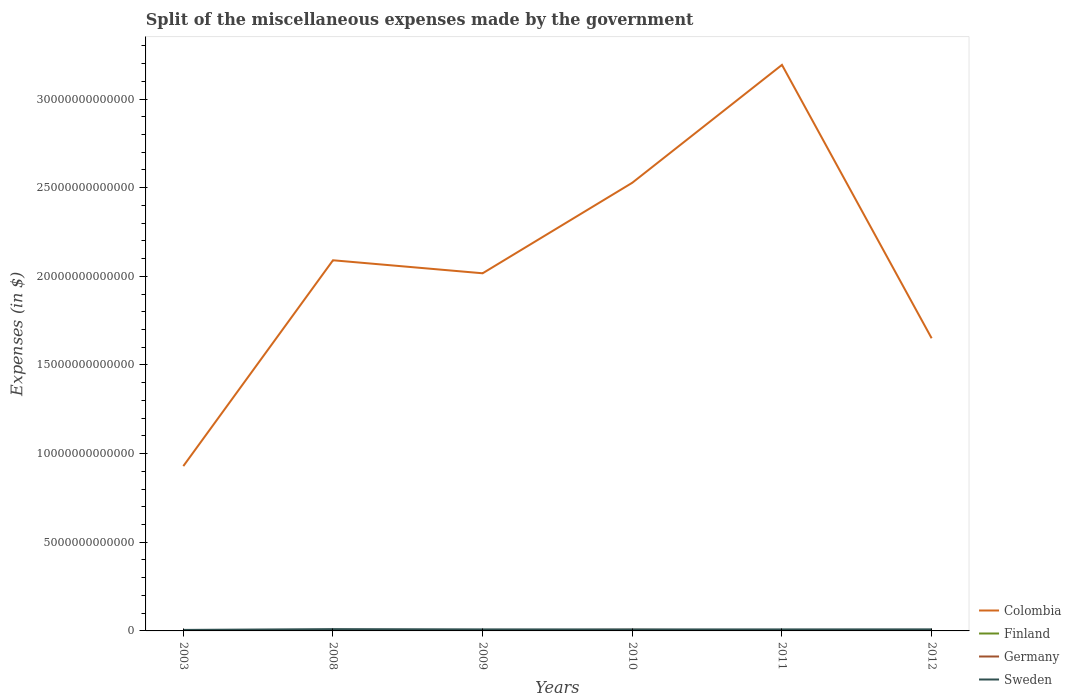How many different coloured lines are there?
Provide a short and direct response. 4. Across all years, what is the maximum miscellaneous expenses made by the government in Germany?
Your answer should be very brief. 2.79e+1. In which year was the miscellaneous expenses made by the government in Colombia maximum?
Your response must be concise. 2003. What is the total miscellaneous expenses made by the government in Colombia in the graph?
Provide a succinct answer. -7.21e+12. What is the difference between the highest and the second highest miscellaneous expenses made by the government in Sweden?
Your answer should be very brief. 4.51e+1. Is the miscellaneous expenses made by the government in Sweden strictly greater than the miscellaneous expenses made by the government in Germany over the years?
Give a very brief answer. No. How many years are there in the graph?
Ensure brevity in your answer.  6. What is the difference between two consecutive major ticks on the Y-axis?
Give a very brief answer. 5.00e+12. Are the values on the major ticks of Y-axis written in scientific E-notation?
Provide a short and direct response. No. Does the graph contain any zero values?
Your answer should be very brief. No. Does the graph contain grids?
Provide a succinct answer. No. Where does the legend appear in the graph?
Provide a succinct answer. Bottom right. How many legend labels are there?
Provide a short and direct response. 4. How are the legend labels stacked?
Keep it short and to the point. Vertical. What is the title of the graph?
Give a very brief answer. Split of the miscellaneous expenses made by the government. What is the label or title of the X-axis?
Offer a terse response. Years. What is the label or title of the Y-axis?
Your response must be concise. Expenses (in $). What is the Expenses (in $) of Colombia in 2003?
Give a very brief answer. 9.30e+12. What is the Expenses (in $) in Finland in 2003?
Your answer should be compact. 3.70e+09. What is the Expenses (in $) of Germany in 2003?
Offer a very short reply. 2.79e+1. What is the Expenses (in $) of Sweden in 2003?
Give a very brief answer. 5.66e+1. What is the Expenses (in $) in Colombia in 2008?
Offer a terse response. 2.09e+13. What is the Expenses (in $) in Finland in 2008?
Ensure brevity in your answer.  4.78e+09. What is the Expenses (in $) of Germany in 2008?
Provide a short and direct response. 3.09e+1. What is the Expenses (in $) of Sweden in 2008?
Provide a succinct answer. 1.02e+11. What is the Expenses (in $) in Colombia in 2009?
Ensure brevity in your answer.  2.02e+13. What is the Expenses (in $) in Finland in 2009?
Provide a short and direct response. 5.07e+09. What is the Expenses (in $) of Germany in 2009?
Offer a very short reply. 3.68e+1. What is the Expenses (in $) in Sweden in 2009?
Provide a succinct answer. 8.61e+1. What is the Expenses (in $) of Colombia in 2010?
Your answer should be very brief. 2.53e+13. What is the Expenses (in $) in Finland in 2010?
Provide a short and direct response. 5.12e+09. What is the Expenses (in $) in Germany in 2010?
Provide a succinct answer. 6.21e+1. What is the Expenses (in $) in Sweden in 2010?
Give a very brief answer. 8.43e+1. What is the Expenses (in $) in Colombia in 2011?
Provide a succinct answer. 3.19e+13. What is the Expenses (in $) of Finland in 2011?
Make the answer very short. 5.28e+09. What is the Expenses (in $) in Germany in 2011?
Keep it short and to the point. 2.88e+1. What is the Expenses (in $) in Sweden in 2011?
Provide a succinct answer. 8.53e+1. What is the Expenses (in $) of Colombia in 2012?
Your response must be concise. 1.65e+13. What is the Expenses (in $) in Finland in 2012?
Ensure brevity in your answer.  5.35e+09. What is the Expenses (in $) of Germany in 2012?
Make the answer very short. 2.88e+1. What is the Expenses (in $) of Sweden in 2012?
Offer a terse response. 8.78e+1. Across all years, what is the maximum Expenses (in $) in Colombia?
Keep it short and to the point. 3.19e+13. Across all years, what is the maximum Expenses (in $) in Finland?
Your answer should be compact. 5.35e+09. Across all years, what is the maximum Expenses (in $) in Germany?
Make the answer very short. 6.21e+1. Across all years, what is the maximum Expenses (in $) of Sweden?
Provide a short and direct response. 1.02e+11. Across all years, what is the minimum Expenses (in $) in Colombia?
Keep it short and to the point. 9.30e+12. Across all years, what is the minimum Expenses (in $) of Finland?
Keep it short and to the point. 3.70e+09. Across all years, what is the minimum Expenses (in $) in Germany?
Make the answer very short. 2.79e+1. Across all years, what is the minimum Expenses (in $) in Sweden?
Offer a very short reply. 5.66e+1. What is the total Expenses (in $) of Colombia in the graph?
Offer a very short reply. 1.24e+14. What is the total Expenses (in $) of Finland in the graph?
Give a very brief answer. 2.93e+1. What is the total Expenses (in $) of Germany in the graph?
Offer a terse response. 2.15e+11. What is the total Expenses (in $) of Sweden in the graph?
Offer a very short reply. 5.02e+11. What is the difference between the Expenses (in $) in Colombia in 2003 and that in 2008?
Offer a very short reply. -1.16e+13. What is the difference between the Expenses (in $) in Finland in 2003 and that in 2008?
Offer a very short reply. -1.08e+09. What is the difference between the Expenses (in $) in Germany in 2003 and that in 2008?
Make the answer very short. -2.96e+09. What is the difference between the Expenses (in $) in Sweden in 2003 and that in 2008?
Ensure brevity in your answer.  -4.51e+1. What is the difference between the Expenses (in $) of Colombia in 2003 and that in 2009?
Ensure brevity in your answer.  -1.09e+13. What is the difference between the Expenses (in $) of Finland in 2003 and that in 2009?
Keep it short and to the point. -1.37e+09. What is the difference between the Expenses (in $) of Germany in 2003 and that in 2009?
Your answer should be compact. -8.92e+09. What is the difference between the Expenses (in $) in Sweden in 2003 and that in 2009?
Your answer should be compact. -2.95e+1. What is the difference between the Expenses (in $) in Colombia in 2003 and that in 2010?
Ensure brevity in your answer.  -1.60e+13. What is the difference between the Expenses (in $) in Finland in 2003 and that in 2010?
Make the answer very short. -1.42e+09. What is the difference between the Expenses (in $) of Germany in 2003 and that in 2010?
Your answer should be compact. -3.42e+1. What is the difference between the Expenses (in $) of Sweden in 2003 and that in 2010?
Make the answer very short. -2.77e+1. What is the difference between the Expenses (in $) in Colombia in 2003 and that in 2011?
Provide a succinct answer. -2.26e+13. What is the difference between the Expenses (in $) in Finland in 2003 and that in 2011?
Your answer should be compact. -1.58e+09. What is the difference between the Expenses (in $) of Germany in 2003 and that in 2011?
Provide a short and direct response. -8.70e+08. What is the difference between the Expenses (in $) of Sweden in 2003 and that in 2011?
Ensure brevity in your answer.  -2.87e+1. What is the difference between the Expenses (in $) of Colombia in 2003 and that in 2012?
Give a very brief answer. -7.21e+12. What is the difference between the Expenses (in $) of Finland in 2003 and that in 2012?
Your answer should be very brief. -1.66e+09. What is the difference between the Expenses (in $) in Germany in 2003 and that in 2012?
Offer a very short reply. -8.30e+08. What is the difference between the Expenses (in $) in Sweden in 2003 and that in 2012?
Offer a terse response. -3.12e+1. What is the difference between the Expenses (in $) in Colombia in 2008 and that in 2009?
Keep it short and to the point. 7.33e+11. What is the difference between the Expenses (in $) of Finland in 2008 and that in 2009?
Offer a very short reply. -2.94e+08. What is the difference between the Expenses (in $) in Germany in 2008 and that in 2009?
Your response must be concise. -5.96e+09. What is the difference between the Expenses (in $) of Sweden in 2008 and that in 2009?
Provide a succinct answer. 1.56e+1. What is the difference between the Expenses (in $) in Colombia in 2008 and that in 2010?
Offer a terse response. -4.37e+12. What is the difference between the Expenses (in $) of Finland in 2008 and that in 2010?
Ensure brevity in your answer.  -3.39e+08. What is the difference between the Expenses (in $) in Germany in 2008 and that in 2010?
Your answer should be compact. -3.12e+1. What is the difference between the Expenses (in $) in Sweden in 2008 and that in 2010?
Make the answer very short. 1.74e+1. What is the difference between the Expenses (in $) in Colombia in 2008 and that in 2011?
Provide a short and direct response. -1.10e+13. What is the difference between the Expenses (in $) in Finland in 2008 and that in 2011?
Make the answer very short. -4.97e+08. What is the difference between the Expenses (in $) of Germany in 2008 and that in 2011?
Your answer should be compact. 2.09e+09. What is the difference between the Expenses (in $) of Sweden in 2008 and that in 2011?
Provide a short and direct response. 1.63e+1. What is the difference between the Expenses (in $) in Colombia in 2008 and that in 2012?
Give a very brief answer. 4.40e+12. What is the difference between the Expenses (in $) in Finland in 2008 and that in 2012?
Provide a succinct answer. -5.75e+08. What is the difference between the Expenses (in $) in Germany in 2008 and that in 2012?
Provide a short and direct response. 2.13e+09. What is the difference between the Expenses (in $) of Sweden in 2008 and that in 2012?
Your answer should be compact. 1.38e+1. What is the difference between the Expenses (in $) of Colombia in 2009 and that in 2010?
Offer a terse response. -5.11e+12. What is the difference between the Expenses (in $) in Finland in 2009 and that in 2010?
Make the answer very short. -4.50e+07. What is the difference between the Expenses (in $) in Germany in 2009 and that in 2010?
Provide a succinct answer. -2.52e+1. What is the difference between the Expenses (in $) of Sweden in 2009 and that in 2010?
Offer a very short reply. 1.77e+09. What is the difference between the Expenses (in $) of Colombia in 2009 and that in 2011?
Provide a succinct answer. -1.18e+13. What is the difference between the Expenses (in $) in Finland in 2009 and that in 2011?
Your response must be concise. -2.03e+08. What is the difference between the Expenses (in $) in Germany in 2009 and that in 2011?
Keep it short and to the point. 8.05e+09. What is the difference between the Expenses (in $) in Sweden in 2009 and that in 2011?
Provide a short and direct response. 7.40e+08. What is the difference between the Expenses (in $) in Colombia in 2009 and that in 2012?
Give a very brief answer. 3.66e+12. What is the difference between the Expenses (in $) of Finland in 2009 and that in 2012?
Provide a short and direct response. -2.81e+08. What is the difference between the Expenses (in $) in Germany in 2009 and that in 2012?
Ensure brevity in your answer.  8.09e+09. What is the difference between the Expenses (in $) in Sweden in 2009 and that in 2012?
Offer a very short reply. -1.77e+09. What is the difference between the Expenses (in $) of Colombia in 2010 and that in 2011?
Provide a succinct answer. -6.65e+12. What is the difference between the Expenses (in $) in Finland in 2010 and that in 2011?
Offer a very short reply. -1.58e+08. What is the difference between the Expenses (in $) in Germany in 2010 and that in 2011?
Make the answer very short. 3.33e+1. What is the difference between the Expenses (in $) in Sweden in 2010 and that in 2011?
Give a very brief answer. -1.03e+09. What is the difference between the Expenses (in $) of Colombia in 2010 and that in 2012?
Offer a terse response. 8.77e+12. What is the difference between the Expenses (in $) of Finland in 2010 and that in 2012?
Give a very brief answer. -2.36e+08. What is the difference between the Expenses (in $) in Germany in 2010 and that in 2012?
Offer a very short reply. 3.33e+1. What is the difference between the Expenses (in $) in Sweden in 2010 and that in 2012?
Ensure brevity in your answer.  -3.54e+09. What is the difference between the Expenses (in $) in Colombia in 2011 and that in 2012?
Offer a terse response. 1.54e+13. What is the difference between the Expenses (in $) of Finland in 2011 and that in 2012?
Your response must be concise. -7.80e+07. What is the difference between the Expenses (in $) in Germany in 2011 and that in 2012?
Ensure brevity in your answer.  4.00e+07. What is the difference between the Expenses (in $) in Sweden in 2011 and that in 2012?
Offer a very short reply. -2.51e+09. What is the difference between the Expenses (in $) in Colombia in 2003 and the Expenses (in $) in Finland in 2008?
Ensure brevity in your answer.  9.29e+12. What is the difference between the Expenses (in $) of Colombia in 2003 and the Expenses (in $) of Germany in 2008?
Offer a very short reply. 9.26e+12. What is the difference between the Expenses (in $) in Colombia in 2003 and the Expenses (in $) in Sweden in 2008?
Offer a very short reply. 9.19e+12. What is the difference between the Expenses (in $) of Finland in 2003 and the Expenses (in $) of Germany in 2008?
Your answer should be very brief. -2.72e+1. What is the difference between the Expenses (in $) in Finland in 2003 and the Expenses (in $) in Sweden in 2008?
Keep it short and to the point. -9.80e+1. What is the difference between the Expenses (in $) of Germany in 2003 and the Expenses (in $) of Sweden in 2008?
Your response must be concise. -7.38e+1. What is the difference between the Expenses (in $) of Colombia in 2003 and the Expenses (in $) of Finland in 2009?
Provide a short and direct response. 9.29e+12. What is the difference between the Expenses (in $) in Colombia in 2003 and the Expenses (in $) in Germany in 2009?
Ensure brevity in your answer.  9.26e+12. What is the difference between the Expenses (in $) of Colombia in 2003 and the Expenses (in $) of Sweden in 2009?
Offer a terse response. 9.21e+12. What is the difference between the Expenses (in $) of Finland in 2003 and the Expenses (in $) of Germany in 2009?
Your answer should be compact. -3.31e+1. What is the difference between the Expenses (in $) of Finland in 2003 and the Expenses (in $) of Sweden in 2009?
Your answer should be very brief. -8.24e+1. What is the difference between the Expenses (in $) of Germany in 2003 and the Expenses (in $) of Sweden in 2009?
Provide a succinct answer. -5.81e+1. What is the difference between the Expenses (in $) of Colombia in 2003 and the Expenses (in $) of Finland in 2010?
Keep it short and to the point. 9.29e+12. What is the difference between the Expenses (in $) of Colombia in 2003 and the Expenses (in $) of Germany in 2010?
Give a very brief answer. 9.23e+12. What is the difference between the Expenses (in $) in Colombia in 2003 and the Expenses (in $) in Sweden in 2010?
Offer a terse response. 9.21e+12. What is the difference between the Expenses (in $) in Finland in 2003 and the Expenses (in $) in Germany in 2010?
Your answer should be very brief. -5.84e+1. What is the difference between the Expenses (in $) of Finland in 2003 and the Expenses (in $) of Sweden in 2010?
Offer a very short reply. -8.06e+1. What is the difference between the Expenses (in $) in Germany in 2003 and the Expenses (in $) in Sweden in 2010?
Make the answer very short. -5.64e+1. What is the difference between the Expenses (in $) of Colombia in 2003 and the Expenses (in $) of Finland in 2011?
Keep it short and to the point. 9.29e+12. What is the difference between the Expenses (in $) of Colombia in 2003 and the Expenses (in $) of Germany in 2011?
Ensure brevity in your answer.  9.27e+12. What is the difference between the Expenses (in $) of Colombia in 2003 and the Expenses (in $) of Sweden in 2011?
Give a very brief answer. 9.21e+12. What is the difference between the Expenses (in $) of Finland in 2003 and the Expenses (in $) of Germany in 2011?
Give a very brief answer. -2.51e+1. What is the difference between the Expenses (in $) in Finland in 2003 and the Expenses (in $) in Sweden in 2011?
Your answer should be very brief. -8.16e+1. What is the difference between the Expenses (in $) of Germany in 2003 and the Expenses (in $) of Sweden in 2011?
Provide a short and direct response. -5.74e+1. What is the difference between the Expenses (in $) of Colombia in 2003 and the Expenses (in $) of Finland in 2012?
Provide a succinct answer. 9.29e+12. What is the difference between the Expenses (in $) in Colombia in 2003 and the Expenses (in $) in Germany in 2012?
Provide a short and direct response. 9.27e+12. What is the difference between the Expenses (in $) in Colombia in 2003 and the Expenses (in $) in Sweden in 2012?
Offer a terse response. 9.21e+12. What is the difference between the Expenses (in $) in Finland in 2003 and the Expenses (in $) in Germany in 2012?
Your response must be concise. -2.51e+1. What is the difference between the Expenses (in $) of Finland in 2003 and the Expenses (in $) of Sweden in 2012?
Keep it short and to the point. -8.41e+1. What is the difference between the Expenses (in $) of Germany in 2003 and the Expenses (in $) of Sweden in 2012?
Your response must be concise. -5.99e+1. What is the difference between the Expenses (in $) of Colombia in 2008 and the Expenses (in $) of Finland in 2009?
Keep it short and to the point. 2.09e+13. What is the difference between the Expenses (in $) of Colombia in 2008 and the Expenses (in $) of Germany in 2009?
Provide a short and direct response. 2.09e+13. What is the difference between the Expenses (in $) of Colombia in 2008 and the Expenses (in $) of Sweden in 2009?
Give a very brief answer. 2.08e+13. What is the difference between the Expenses (in $) of Finland in 2008 and the Expenses (in $) of Germany in 2009?
Your response must be concise. -3.21e+1. What is the difference between the Expenses (in $) in Finland in 2008 and the Expenses (in $) in Sweden in 2009?
Provide a short and direct response. -8.13e+1. What is the difference between the Expenses (in $) in Germany in 2008 and the Expenses (in $) in Sweden in 2009?
Your answer should be compact. -5.52e+1. What is the difference between the Expenses (in $) of Colombia in 2008 and the Expenses (in $) of Finland in 2010?
Keep it short and to the point. 2.09e+13. What is the difference between the Expenses (in $) of Colombia in 2008 and the Expenses (in $) of Germany in 2010?
Offer a terse response. 2.08e+13. What is the difference between the Expenses (in $) in Colombia in 2008 and the Expenses (in $) in Sweden in 2010?
Keep it short and to the point. 2.08e+13. What is the difference between the Expenses (in $) of Finland in 2008 and the Expenses (in $) of Germany in 2010?
Provide a short and direct response. -5.73e+1. What is the difference between the Expenses (in $) of Finland in 2008 and the Expenses (in $) of Sweden in 2010?
Keep it short and to the point. -7.95e+1. What is the difference between the Expenses (in $) in Germany in 2008 and the Expenses (in $) in Sweden in 2010?
Provide a succinct answer. -5.34e+1. What is the difference between the Expenses (in $) in Colombia in 2008 and the Expenses (in $) in Finland in 2011?
Keep it short and to the point. 2.09e+13. What is the difference between the Expenses (in $) of Colombia in 2008 and the Expenses (in $) of Germany in 2011?
Make the answer very short. 2.09e+13. What is the difference between the Expenses (in $) in Colombia in 2008 and the Expenses (in $) in Sweden in 2011?
Your response must be concise. 2.08e+13. What is the difference between the Expenses (in $) of Finland in 2008 and the Expenses (in $) of Germany in 2011?
Offer a very short reply. -2.40e+1. What is the difference between the Expenses (in $) in Finland in 2008 and the Expenses (in $) in Sweden in 2011?
Provide a short and direct response. -8.05e+1. What is the difference between the Expenses (in $) in Germany in 2008 and the Expenses (in $) in Sweden in 2011?
Your answer should be very brief. -5.44e+1. What is the difference between the Expenses (in $) in Colombia in 2008 and the Expenses (in $) in Finland in 2012?
Provide a succinct answer. 2.09e+13. What is the difference between the Expenses (in $) in Colombia in 2008 and the Expenses (in $) in Germany in 2012?
Provide a short and direct response. 2.09e+13. What is the difference between the Expenses (in $) of Colombia in 2008 and the Expenses (in $) of Sweden in 2012?
Give a very brief answer. 2.08e+13. What is the difference between the Expenses (in $) of Finland in 2008 and the Expenses (in $) of Germany in 2012?
Offer a terse response. -2.40e+1. What is the difference between the Expenses (in $) in Finland in 2008 and the Expenses (in $) in Sweden in 2012?
Ensure brevity in your answer.  -8.31e+1. What is the difference between the Expenses (in $) in Germany in 2008 and the Expenses (in $) in Sweden in 2012?
Keep it short and to the point. -5.70e+1. What is the difference between the Expenses (in $) in Colombia in 2009 and the Expenses (in $) in Finland in 2010?
Your answer should be compact. 2.02e+13. What is the difference between the Expenses (in $) in Colombia in 2009 and the Expenses (in $) in Germany in 2010?
Your answer should be compact. 2.01e+13. What is the difference between the Expenses (in $) in Colombia in 2009 and the Expenses (in $) in Sweden in 2010?
Provide a succinct answer. 2.01e+13. What is the difference between the Expenses (in $) of Finland in 2009 and the Expenses (in $) of Germany in 2010?
Offer a very short reply. -5.70e+1. What is the difference between the Expenses (in $) of Finland in 2009 and the Expenses (in $) of Sweden in 2010?
Ensure brevity in your answer.  -7.92e+1. What is the difference between the Expenses (in $) of Germany in 2009 and the Expenses (in $) of Sweden in 2010?
Provide a short and direct response. -4.74e+1. What is the difference between the Expenses (in $) of Colombia in 2009 and the Expenses (in $) of Finland in 2011?
Provide a short and direct response. 2.02e+13. What is the difference between the Expenses (in $) of Colombia in 2009 and the Expenses (in $) of Germany in 2011?
Keep it short and to the point. 2.01e+13. What is the difference between the Expenses (in $) of Colombia in 2009 and the Expenses (in $) of Sweden in 2011?
Keep it short and to the point. 2.01e+13. What is the difference between the Expenses (in $) in Finland in 2009 and the Expenses (in $) in Germany in 2011?
Provide a short and direct response. -2.37e+1. What is the difference between the Expenses (in $) of Finland in 2009 and the Expenses (in $) of Sweden in 2011?
Offer a very short reply. -8.03e+1. What is the difference between the Expenses (in $) of Germany in 2009 and the Expenses (in $) of Sweden in 2011?
Provide a short and direct response. -4.85e+1. What is the difference between the Expenses (in $) in Colombia in 2009 and the Expenses (in $) in Finland in 2012?
Give a very brief answer. 2.02e+13. What is the difference between the Expenses (in $) of Colombia in 2009 and the Expenses (in $) of Germany in 2012?
Offer a very short reply. 2.01e+13. What is the difference between the Expenses (in $) in Colombia in 2009 and the Expenses (in $) in Sweden in 2012?
Ensure brevity in your answer.  2.01e+13. What is the difference between the Expenses (in $) of Finland in 2009 and the Expenses (in $) of Germany in 2012?
Offer a terse response. -2.37e+1. What is the difference between the Expenses (in $) of Finland in 2009 and the Expenses (in $) of Sweden in 2012?
Offer a very short reply. -8.28e+1. What is the difference between the Expenses (in $) of Germany in 2009 and the Expenses (in $) of Sweden in 2012?
Offer a terse response. -5.10e+1. What is the difference between the Expenses (in $) in Colombia in 2010 and the Expenses (in $) in Finland in 2011?
Keep it short and to the point. 2.53e+13. What is the difference between the Expenses (in $) of Colombia in 2010 and the Expenses (in $) of Germany in 2011?
Provide a succinct answer. 2.52e+13. What is the difference between the Expenses (in $) of Colombia in 2010 and the Expenses (in $) of Sweden in 2011?
Offer a very short reply. 2.52e+13. What is the difference between the Expenses (in $) of Finland in 2010 and the Expenses (in $) of Germany in 2011?
Your answer should be very brief. -2.37e+1. What is the difference between the Expenses (in $) in Finland in 2010 and the Expenses (in $) in Sweden in 2011?
Give a very brief answer. -8.02e+1. What is the difference between the Expenses (in $) in Germany in 2010 and the Expenses (in $) in Sweden in 2011?
Give a very brief answer. -2.32e+1. What is the difference between the Expenses (in $) of Colombia in 2010 and the Expenses (in $) of Finland in 2012?
Give a very brief answer. 2.53e+13. What is the difference between the Expenses (in $) of Colombia in 2010 and the Expenses (in $) of Germany in 2012?
Give a very brief answer. 2.52e+13. What is the difference between the Expenses (in $) of Colombia in 2010 and the Expenses (in $) of Sweden in 2012?
Provide a short and direct response. 2.52e+13. What is the difference between the Expenses (in $) of Finland in 2010 and the Expenses (in $) of Germany in 2012?
Your response must be concise. -2.36e+1. What is the difference between the Expenses (in $) of Finland in 2010 and the Expenses (in $) of Sweden in 2012?
Ensure brevity in your answer.  -8.27e+1. What is the difference between the Expenses (in $) in Germany in 2010 and the Expenses (in $) in Sweden in 2012?
Make the answer very short. -2.58e+1. What is the difference between the Expenses (in $) in Colombia in 2011 and the Expenses (in $) in Finland in 2012?
Your answer should be very brief. 3.19e+13. What is the difference between the Expenses (in $) of Colombia in 2011 and the Expenses (in $) of Germany in 2012?
Offer a very short reply. 3.19e+13. What is the difference between the Expenses (in $) of Colombia in 2011 and the Expenses (in $) of Sweden in 2012?
Provide a short and direct response. 3.18e+13. What is the difference between the Expenses (in $) of Finland in 2011 and the Expenses (in $) of Germany in 2012?
Your answer should be very brief. -2.35e+1. What is the difference between the Expenses (in $) in Finland in 2011 and the Expenses (in $) in Sweden in 2012?
Give a very brief answer. -8.26e+1. What is the difference between the Expenses (in $) in Germany in 2011 and the Expenses (in $) in Sweden in 2012?
Offer a very short reply. -5.90e+1. What is the average Expenses (in $) of Colombia per year?
Keep it short and to the point. 2.07e+13. What is the average Expenses (in $) in Finland per year?
Your response must be concise. 4.88e+09. What is the average Expenses (in $) of Germany per year?
Provide a succinct answer. 3.59e+1. What is the average Expenses (in $) in Sweden per year?
Keep it short and to the point. 8.36e+1. In the year 2003, what is the difference between the Expenses (in $) in Colombia and Expenses (in $) in Finland?
Make the answer very short. 9.29e+12. In the year 2003, what is the difference between the Expenses (in $) of Colombia and Expenses (in $) of Germany?
Give a very brief answer. 9.27e+12. In the year 2003, what is the difference between the Expenses (in $) of Colombia and Expenses (in $) of Sweden?
Offer a very short reply. 9.24e+12. In the year 2003, what is the difference between the Expenses (in $) of Finland and Expenses (in $) of Germany?
Ensure brevity in your answer.  -2.42e+1. In the year 2003, what is the difference between the Expenses (in $) in Finland and Expenses (in $) in Sweden?
Offer a terse response. -5.29e+1. In the year 2003, what is the difference between the Expenses (in $) in Germany and Expenses (in $) in Sweden?
Your answer should be compact. -2.87e+1. In the year 2008, what is the difference between the Expenses (in $) of Colombia and Expenses (in $) of Finland?
Provide a short and direct response. 2.09e+13. In the year 2008, what is the difference between the Expenses (in $) in Colombia and Expenses (in $) in Germany?
Offer a terse response. 2.09e+13. In the year 2008, what is the difference between the Expenses (in $) of Colombia and Expenses (in $) of Sweden?
Give a very brief answer. 2.08e+13. In the year 2008, what is the difference between the Expenses (in $) in Finland and Expenses (in $) in Germany?
Provide a short and direct response. -2.61e+1. In the year 2008, what is the difference between the Expenses (in $) in Finland and Expenses (in $) in Sweden?
Give a very brief answer. -9.69e+1. In the year 2008, what is the difference between the Expenses (in $) in Germany and Expenses (in $) in Sweden?
Give a very brief answer. -7.08e+1. In the year 2009, what is the difference between the Expenses (in $) in Colombia and Expenses (in $) in Finland?
Provide a succinct answer. 2.02e+13. In the year 2009, what is the difference between the Expenses (in $) of Colombia and Expenses (in $) of Germany?
Your answer should be very brief. 2.01e+13. In the year 2009, what is the difference between the Expenses (in $) of Colombia and Expenses (in $) of Sweden?
Provide a succinct answer. 2.01e+13. In the year 2009, what is the difference between the Expenses (in $) in Finland and Expenses (in $) in Germany?
Ensure brevity in your answer.  -3.18e+1. In the year 2009, what is the difference between the Expenses (in $) in Finland and Expenses (in $) in Sweden?
Your answer should be very brief. -8.10e+1. In the year 2009, what is the difference between the Expenses (in $) of Germany and Expenses (in $) of Sweden?
Your answer should be very brief. -4.92e+1. In the year 2010, what is the difference between the Expenses (in $) of Colombia and Expenses (in $) of Finland?
Offer a terse response. 2.53e+13. In the year 2010, what is the difference between the Expenses (in $) of Colombia and Expenses (in $) of Germany?
Your answer should be compact. 2.52e+13. In the year 2010, what is the difference between the Expenses (in $) in Colombia and Expenses (in $) in Sweden?
Provide a short and direct response. 2.52e+13. In the year 2010, what is the difference between the Expenses (in $) of Finland and Expenses (in $) of Germany?
Offer a very short reply. -5.70e+1. In the year 2010, what is the difference between the Expenses (in $) in Finland and Expenses (in $) in Sweden?
Keep it short and to the point. -7.92e+1. In the year 2010, what is the difference between the Expenses (in $) in Germany and Expenses (in $) in Sweden?
Provide a succinct answer. -2.22e+1. In the year 2011, what is the difference between the Expenses (in $) in Colombia and Expenses (in $) in Finland?
Make the answer very short. 3.19e+13. In the year 2011, what is the difference between the Expenses (in $) of Colombia and Expenses (in $) of Germany?
Your answer should be very brief. 3.19e+13. In the year 2011, what is the difference between the Expenses (in $) of Colombia and Expenses (in $) of Sweden?
Give a very brief answer. 3.18e+13. In the year 2011, what is the difference between the Expenses (in $) of Finland and Expenses (in $) of Germany?
Offer a very short reply. -2.35e+1. In the year 2011, what is the difference between the Expenses (in $) of Finland and Expenses (in $) of Sweden?
Keep it short and to the point. -8.00e+1. In the year 2011, what is the difference between the Expenses (in $) of Germany and Expenses (in $) of Sweden?
Offer a terse response. -5.65e+1. In the year 2012, what is the difference between the Expenses (in $) of Colombia and Expenses (in $) of Finland?
Ensure brevity in your answer.  1.65e+13. In the year 2012, what is the difference between the Expenses (in $) in Colombia and Expenses (in $) in Germany?
Offer a very short reply. 1.65e+13. In the year 2012, what is the difference between the Expenses (in $) in Colombia and Expenses (in $) in Sweden?
Your response must be concise. 1.64e+13. In the year 2012, what is the difference between the Expenses (in $) of Finland and Expenses (in $) of Germany?
Your response must be concise. -2.34e+1. In the year 2012, what is the difference between the Expenses (in $) of Finland and Expenses (in $) of Sweden?
Offer a very short reply. -8.25e+1. In the year 2012, what is the difference between the Expenses (in $) in Germany and Expenses (in $) in Sweden?
Give a very brief answer. -5.91e+1. What is the ratio of the Expenses (in $) of Colombia in 2003 to that in 2008?
Your answer should be very brief. 0.44. What is the ratio of the Expenses (in $) of Finland in 2003 to that in 2008?
Ensure brevity in your answer.  0.77. What is the ratio of the Expenses (in $) in Germany in 2003 to that in 2008?
Your answer should be compact. 0.9. What is the ratio of the Expenses (in $) of Sweden in 2003 to that in 2008?
Provide a short and direct response. 0.56. What is the ratio of the Expenses (in $) of Colombia in 2003 to that in 2009?
Keep it short and to the point. 0.46. What is the ratio of the Expenses (in $) of Finland in 2003 to that in 2009?
Keep it short and to the point. 0.73. What is the ratio of the Expenses (in $) of Germany in 2003 to that in 2009?
Provide a succinct answer. 0.76. What is the ratio of the Expenses (in $) in Sweden in 2003 to that in 2009?
Give a very brief answer. 0.66. What is the ratio of the Expenses (in $) in Colombia in 2003 to that in 2010?
Your response must be concise. 0.37. What is the ratio of the Expenses (in $) of Finland in 2003 to that in 2010?
Provide a succinct answer. 0.72. What is the ratio of the Expenses (in $) of Germany in 2003 to that in 2010?
Offer a terse response. 0.45. What is the ratio of the Expenses (in $) of Sweden in 2003 to that in 2010?
Provide a short and direct response. 0.67. What is the ratio of the Expenses (in $) of Colombia in 2003 to that in 2011?
Make the answer very short. 0.29. What is the ratio of the Expenses (in $) in Finland in 2003 to that in 2011?
Keep it short and to the point. 0.7. What is the ratio of the Expenses (in $) in Germany in 2003 to that in 2011?
Provide a short and direct response. 0.97. What is the ratio of the Expenses (in $) in Sweden in 2003 to that in 2011?
Ensure brevity in your answer.  0.66. What is the ratio of the Expenses (in $) in Colombia in 2003 to that in 2012?
Your answer should be very brief. 0.56. What is the ratio of the Expenses (in $) in Finland in 2003 to that in 2012?
Offer a very short reply. 0.69. What is the ratio of the Expenses (in $) of Germany in 2003 to that in 2012?
Your answer should be compact. 0.97. What is the ratio of the Expenses (in $) in Sweden in 2003 to that in 2012?
Provide a short and direct response. 0.64. What is the ratio of the Expenses (in $) of Colombia in 2008 to that in 2009?
Offer a very short reply. 1.04. What is the ratio of the Expenses (in $) of Finland in 2008 to that in 2009?
Provide a short and direct response. 0.94. What is the ratio of the Expenses (in $) of Germany in 2008 to that in 2009?
Your answer should be very brief. 0.84. What is the ratio of the Expenses (in $) in Sweden in 2008 to that in 2009?
Ensure brevity in your answer.  1.18. What is the ratio of the Expenses (in $) of Colombia in 2008 to that in 2010?
Offer a terse response. 0.83. What is the ratio of the Expenses (in $) of Finland in 2008 to that in 2010?
Give a very brief answer. 0.93. What is the ratio of the Expenses (in $) of Germany in 2008 to that in 2010?
Provide a succinct answer. 0.5. What is the ratio of the Expenses (in $) of Sweden in 2008 to that in 2010?
Offer a terse response. 1.21. What is the ratio of the Expenses (in $) in Colombia in 2008 to that in 2011?
Ensure brevity in your answer.  0.65. What is the ratio of the Expenses (in $) of Finland in 2008 to that in 2011?
Your answer should be very brief. 0.91. What is the ratio of the Expenses (in $) in Germany in 2008 to that in 2011?
Your response must be concise. 1.07. What is the ratio of the Expenses (in $) in Sweden in 2008 to that in 2011?
Your answer should be compact. 1.19. What is the ratio of the Expenses (in $) in Colombia in 2008 to that in 2012?
Provide a short and direct response. 1.27. What is the ratio of the Expenses (in $) of Finland in 2008 to that in 2012?
Make the answer very short. 0.89. What is the ratio of the Expenses (in $) of Germany in 2008 to that in 2012?
Your response must be concise. 1.07. What is the ratio of the Expenses (in $) of Sweden in 2008 to that in 2012?
Your response must be concise. 1.16. What is the ratio of the Expenses (in $) of Colombia in 2009 to that in 2010?
Make the answer very short. 0.8. What is the ratio of the Expenses (in $) in Finland in 2009 to that in 2010?
Your response must be concise. 0.99. What is the ratio of the Expenses (in $) in Germany in 2009 to that in 2010?
Offer a very short reply. 0.59. What is the ratio of the Expenses (in $) of Colombia in 2009 to that in 2011?
Keep it short and to the point. 0.63. What is the ratio of the Expenses (in $) of Finland in 2009 to that in 2011?
Give a very brief answer. 0.96. What is the ratio of the Expenses (in $) in Germany in 2009 to that in 2011?
Make the answer very short. 1.28. What is the ratio of the Expenses (in $) of Sweden in 2009 to that in 2011?
Ensure brevity in your answer.  1.01. What is the ratio of the Expenses (in $) in Colombia in 2009 to that in 2012?
Ensure brevity in your answer.  1.22. What is the ratio of the Expenses (in $) of Finland in 2009 to that in 2012?
Your answer should be compact. 0.95. What is the ratio of the Expenses (in $) in Germany in 2009 to that in 2012?
Provide a short and direct response. 1.28. What is the ratio of the Expenses (in $) of Sweden in 2009 to that in 2012?
Your response must be concise. 0.98. What is the ratio of the Expenses (in $) in Colombia in 2010 to that in 2011?
Ensure brevity in your answer.  0.79. What is the ratio of the Expenses (in $) of Finland in 2010 to that in 2011?
Ensure brevity in your answer.  0.97. What is the ratio of the Expenses (in $) in Germany in 2010 to that in 2011?
Your response must be concise. 2.16. What is the ratio of the Expenses (in $) in Sweden in 2010 to that in 2011?
Offer a terse response. 0.99. What is the ratio of the Expenses (in $) of Colombia in 2010 to that in 2012?
Give a very brief answer. 1.53. What is the ratio of the Expenses (in $) of Finland in 2010 to that in 2012?
Offer a very short reply. 0.96. What is the ratio of the Expenses (in $) of Germany in 2010 to that in 2012?
Ensure brevity in your answer.  2.16. What is the ratio of the Expenses (in $) in Sweden in 2010 to that in 2012?
Give a very brief answer. 0.96. What is the ratio of the Expenses (in $) in Colombia in 2011 to that in 2012?
Provide a succinct answer. 1.93. What is the ratio of the Expenses (in $) in Finland in 2011 to that in 2012?
Offer a terse response. 0.99. What is the ratio of the Expenses (in $) in Germany in 2011 to that in 2012?
Your answer should be very brief. 1. What is the ratio of the Expenses (in $) of Sweden in 2011 to that in 2012?
Your response must be concise. 0.97. What is the difference between the highest and the second highest Expenses (in $) of Colombia?
Provide a succinct answer. 6.65e+12. What is the difference between the highest and the second highest Expenses (in $) of Finland?
Make the answer very short. 7.80e+07. What is the difference between the highest and the second highest Expenses (in $) in Germany?
Make the answer very short. 2.52e+1. What is the difference between the highest and the second highest Expenses (in $) in Sweden?
Your answer should be very brief. 1.38e+1. What is the difference between the highest and the lowest Expenses (in $) in Colombia?
Your response must be concise. 2.26e+13. What is the difference between the highest and the lowest Expenses (in $) of Finland?
Your answer should be very brief. 1.66e+09. What is the difference between the highest and the lowest Expenses (in $) of Germany?
Keep it short and to the point. 3.42e+1. What is the difference between the highest and the lowest Expenses (in $) of Sweden?
Make the answer very short. 4.51e+1. 